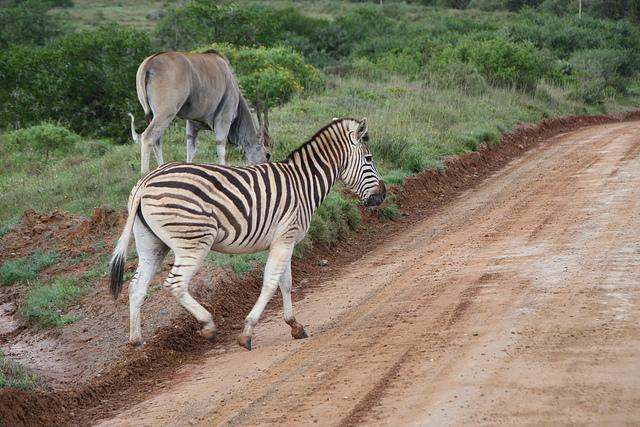What is the zebra on the left about to step into?

Choices:
A) grass
B) road
C) water
D) hay road 